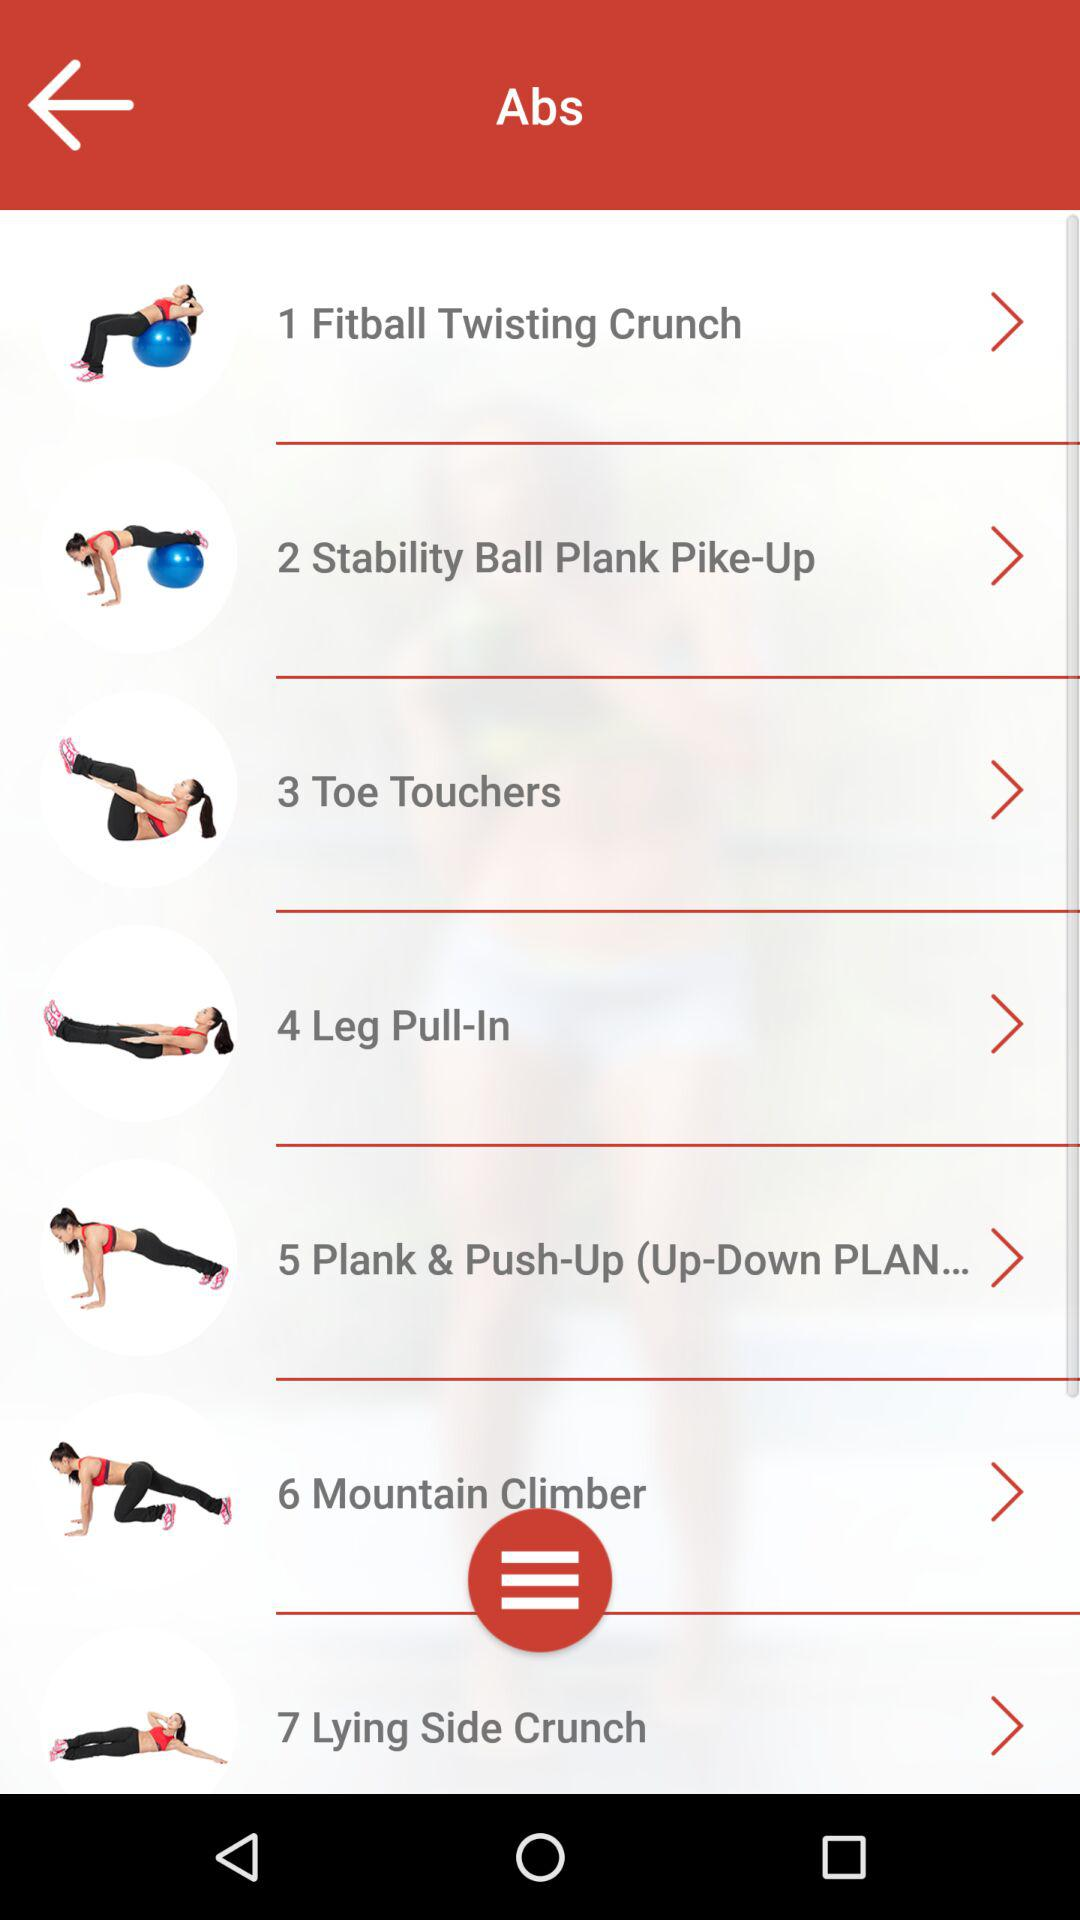How many exercises are there in this workout?
Answer the question using a single word or phrase. 7 